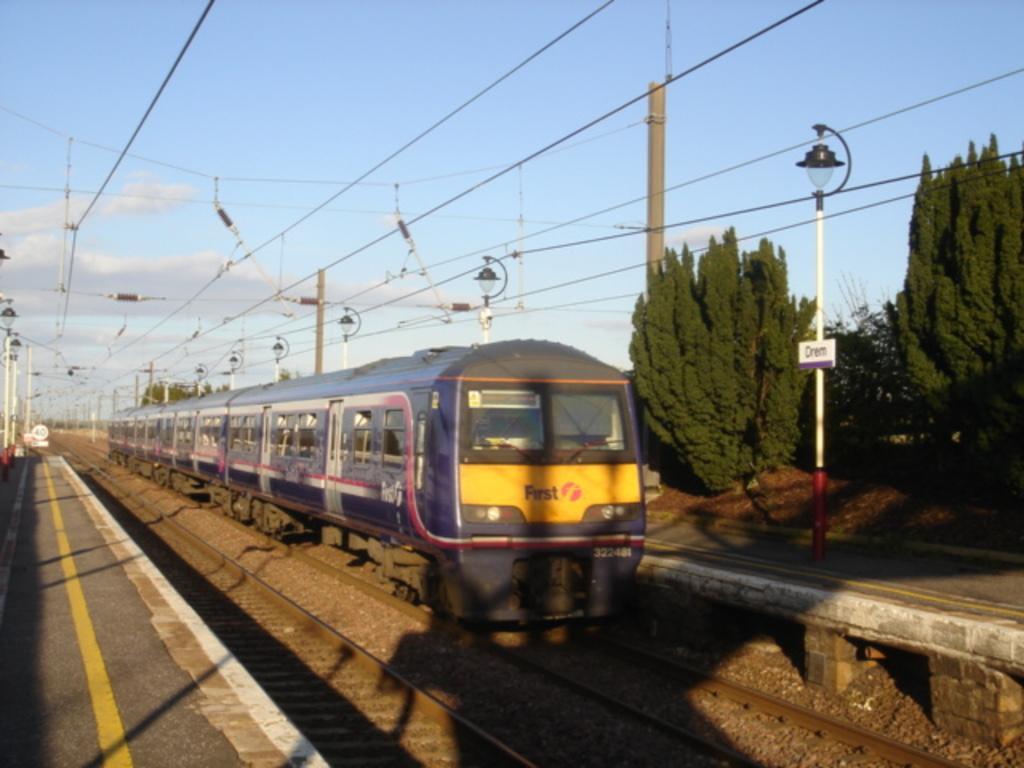Describe this image in one or two sentences. The picture consists of railway tracks, train and platform. On the the right there are trees and street light. In the background there are cables, current poles and street lights. Sky is clear and it is sunny. 